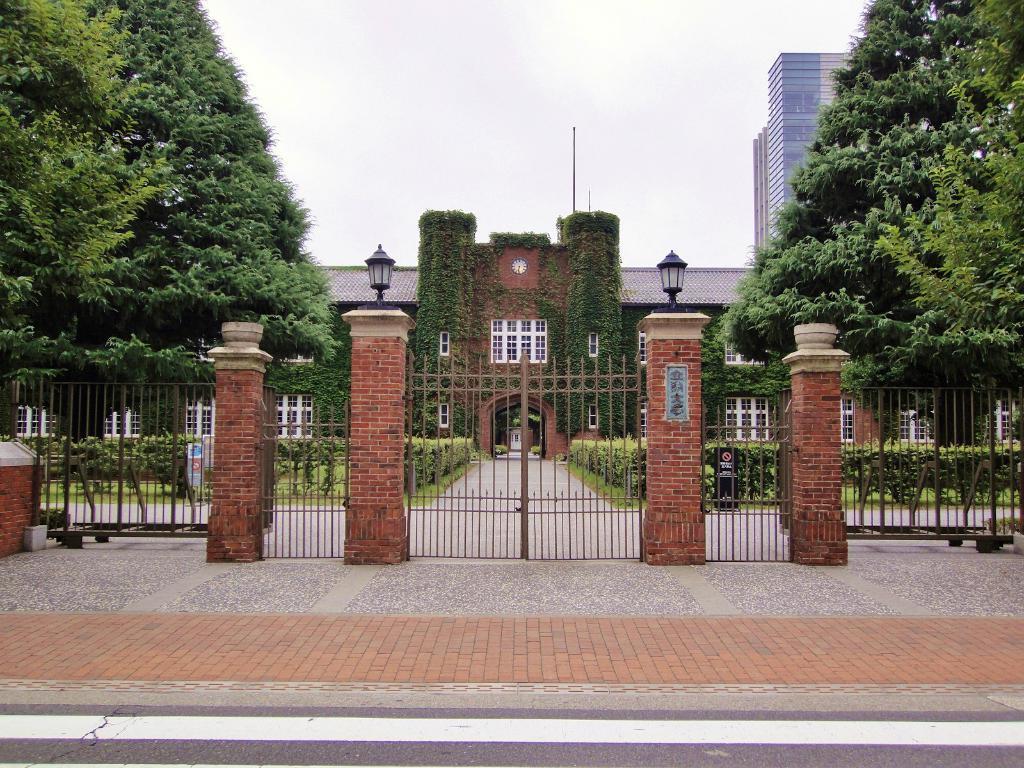Describe this image in one or two sentences. In this picture we can see a building. There are few lanterns on the pillars. We can see a gate. There are few trees and buildings in the background. 